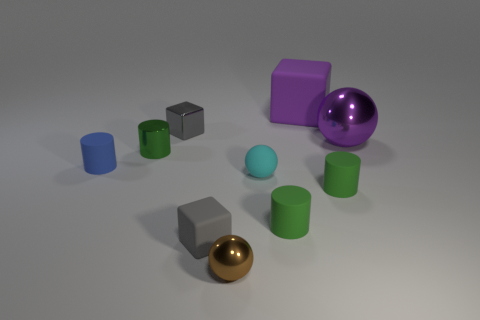Do the matte cube that is in front of the big purple metallic thing and the metallic sphere that is on the right side of the small brown object have the same color?
Offer a very short reply. No. There is a big thing on the left side of the large purple shiny ball; is there a metal block in front of it?
Offer a terse response. Yes. Do the tiny shiny thing that is on the right side of the tiny gray matte cube and the small green object behind the small cyan rubber sphere have the same shape?
Keep it short and to the point. No. Are the gray object that is behind the blue cylinder and the green object behind the tiny blue cylinder made of the same material?
Offer a terse response. Yes. There is a large object behind the tiny cube behind the green metallic cylinder; what is it made of?
Your answer should be compact. Rubber. The shiny object that is right of the shiny sphere that is in front of the green cylinder behind the small cyan sphere is what shape?
Your answer should be compact. Sphere. There is a tiny blue object that is the same shape as the green shiny thing; what is it made of?
Give a very brief answer. Rubber. How many cyan shiny things are there?
Offer a terse response. 0. There is a metal thing right of the tiny brown metal ball; what shape is it?
Your answer should be compact. Sphere. What is the color of the block that is on the right side of the sphere that is in front of the small gray block in front of the tiny cyan rubber thing?
Offer a very short reply. Purple. 